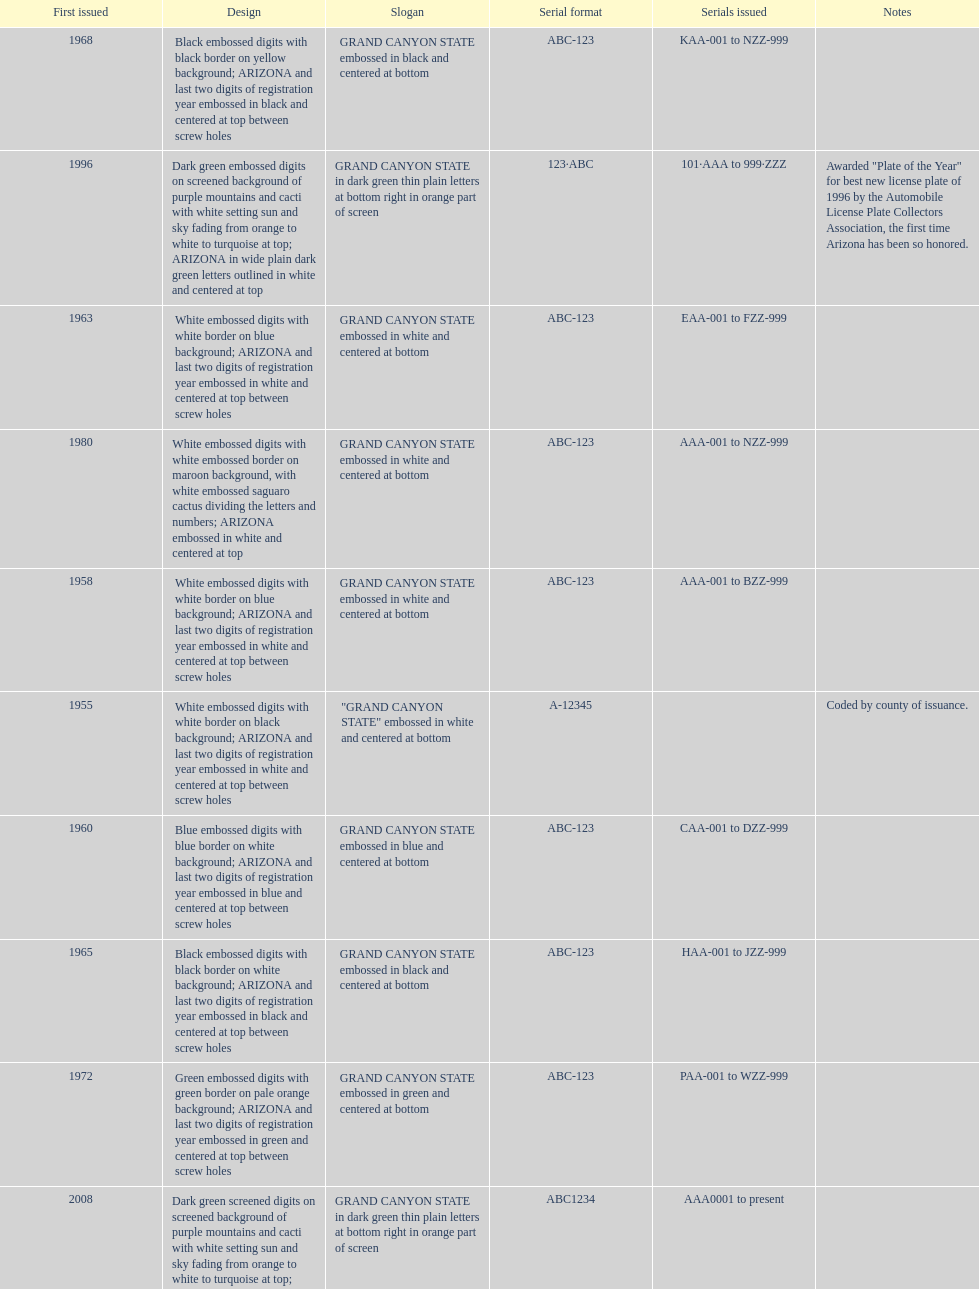What was year was the first arizona license plate made? 1955. 